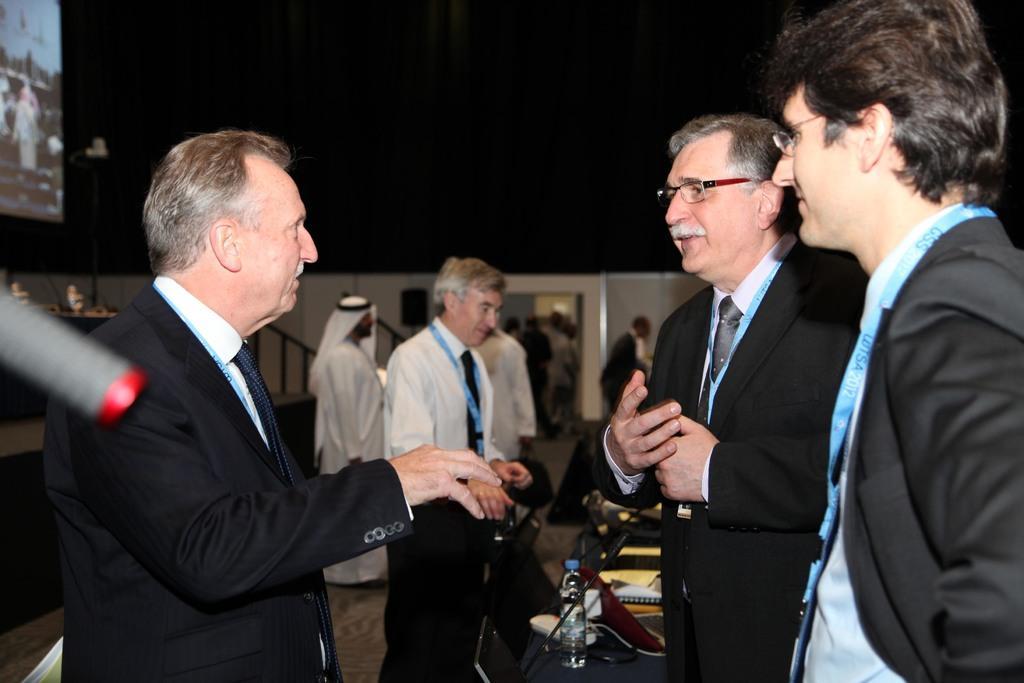Please provide a concise description of this image. In this picture we can see a group of people standing and on the left side of the people there is a screen. Behind the people there is a wall and it looks like a table and on the table there is a bottle, books and some objects. Behind the wall there is the dark background. 